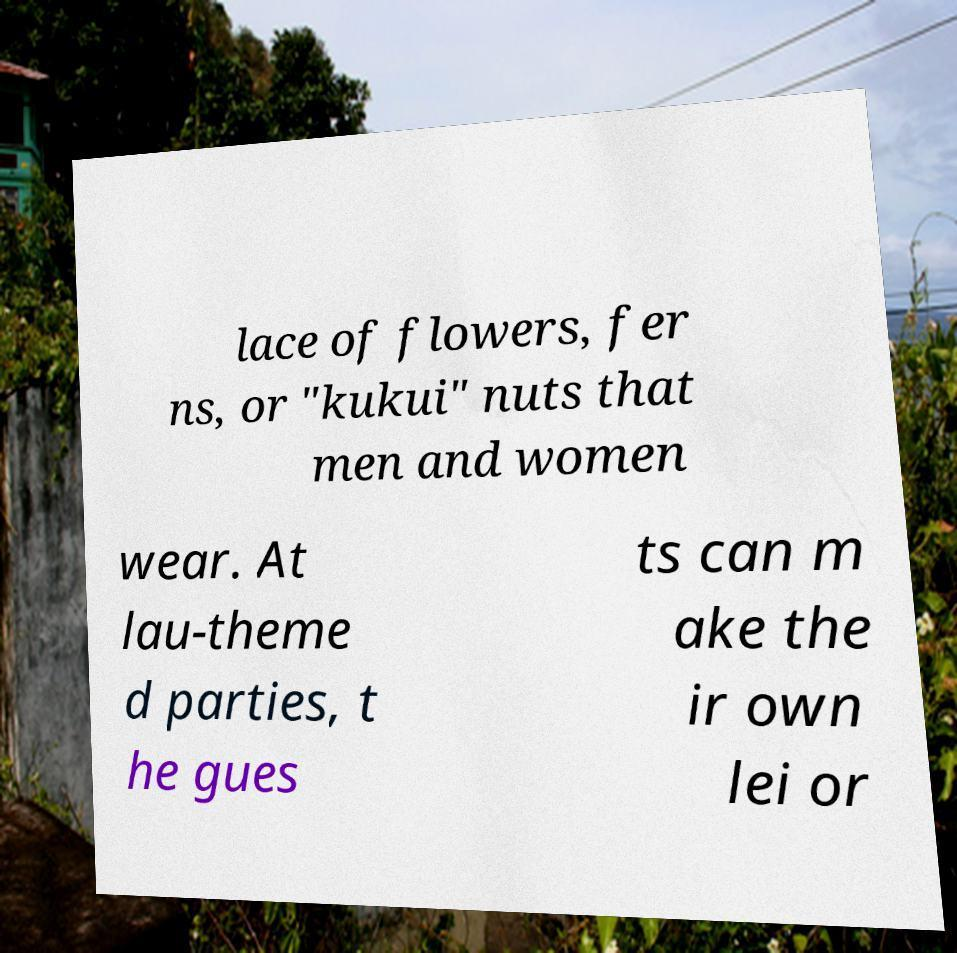Please read and relay the text visible in this image. What does it say? lace of flowers, fer ns, or "kukui" nuts that men and women wear. At lau-theme d parties, t he gues ts can m ake the ir own lei or 